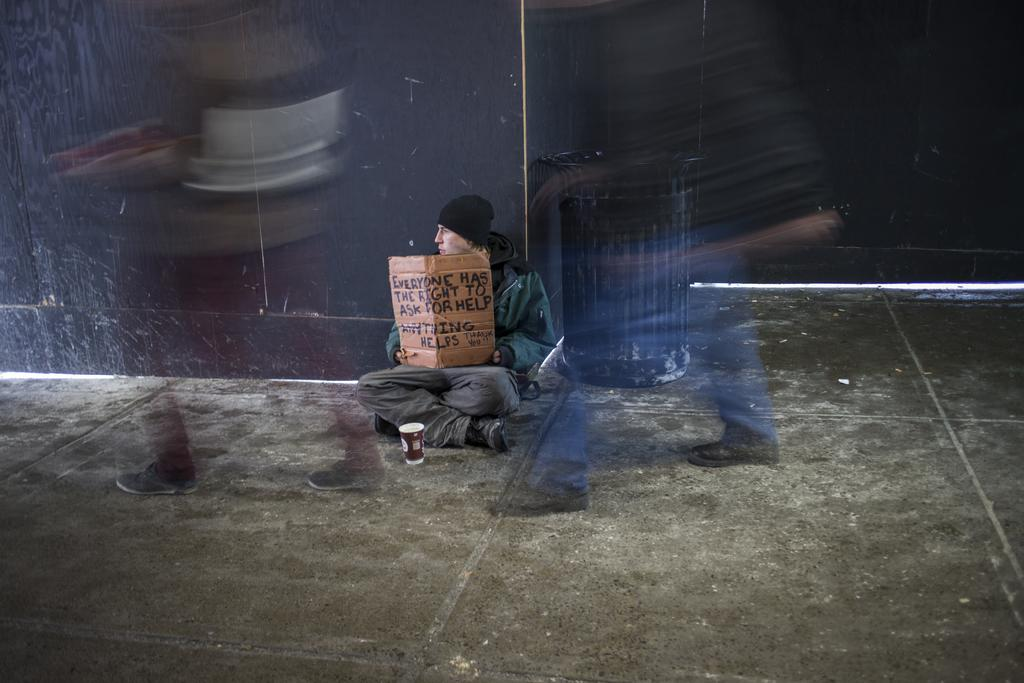What is the person in the image doing? The person is sitting in the image. What is the person holding in the image? The person is holding a placard. What can be read on the placard? There is text on the placard. What is placed in front of the person? There is a cup in front of the person. What is visible behind the person? There is a wall behind the person. What type of rabbit is sitting next to the person in the image? There is no rabbit present in the image. What authority does the person in the image have? The image does not provide any information about the person's authority. 